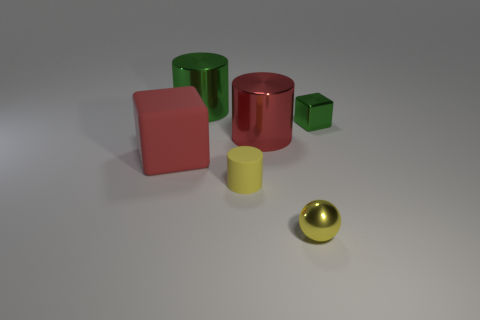Subtract all big metal cylinders. How many cylinders are left? 1 Add 4 small gray shiny cubes. How many objects exist? 10 Subtract all spheres. How many objects are left? 5 Add 3 red shiny objects. How many red shiny objects exist? 4 Subtract 0 gray blocks. How many objects are left? 6 Subtract all cyan rubber cylinders. Subtract all big red shiny cylinders. How many objects are left? 5 Add 6 big green cylinders. How many big green cylinders are left? 7 